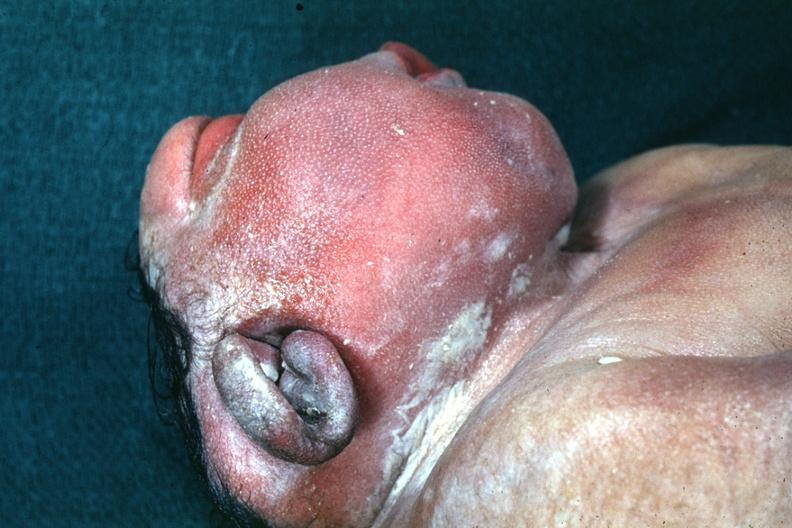what is present?
Answer the question using a single word or phrase. Anencephaly 